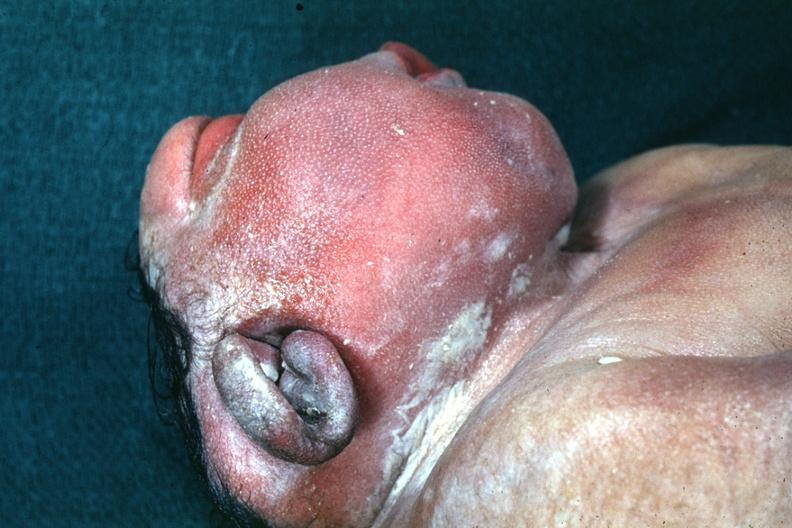what is present?
Answer the question using a single word or phrase. Anencephaly 